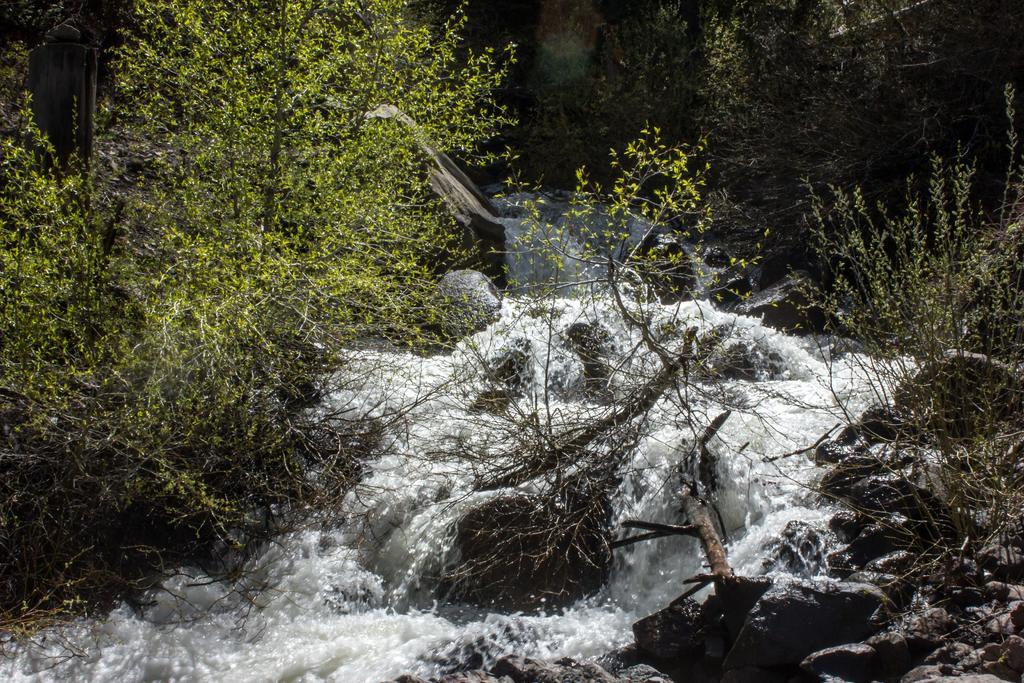How would you summarize this image in a sentence or two? In this image there is a water flow in the middle. There are trees on either side of it. At the bottom there are stones. 